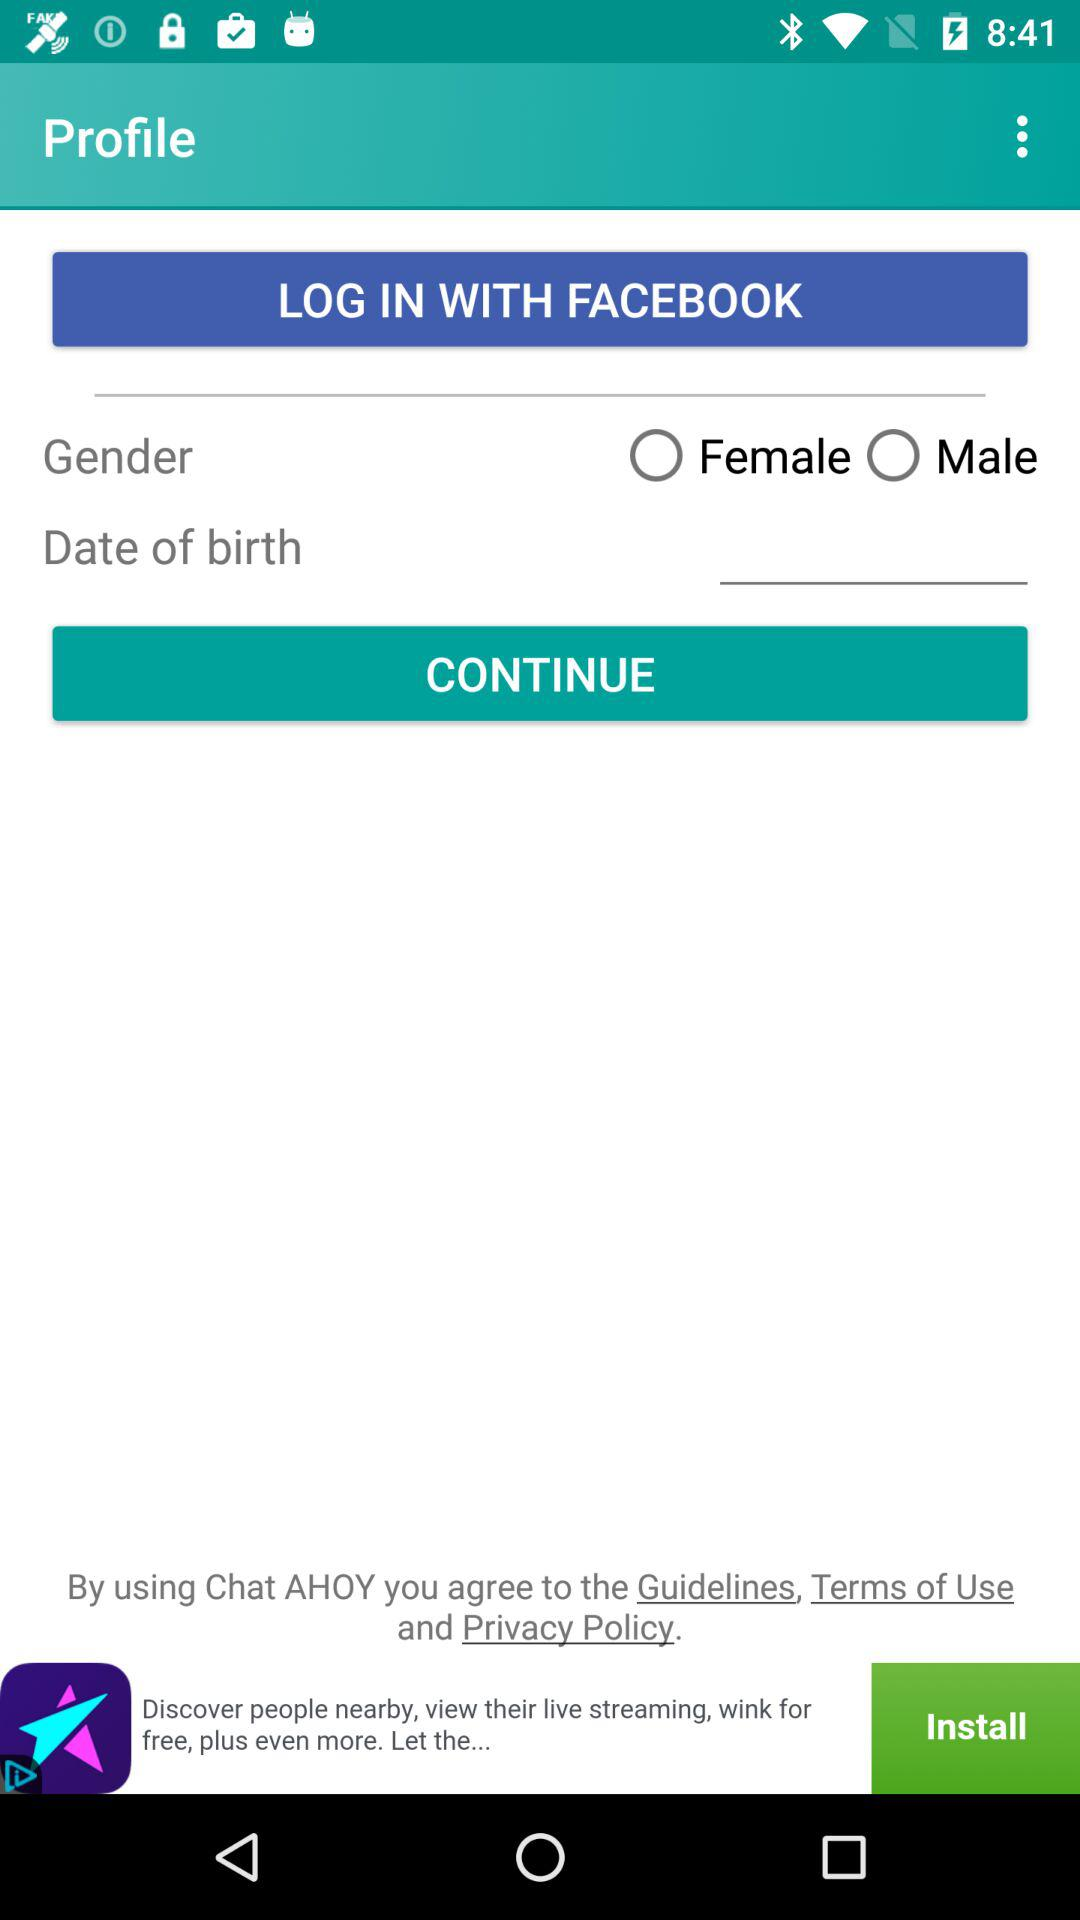What options are given for gender? The options are female and male. 